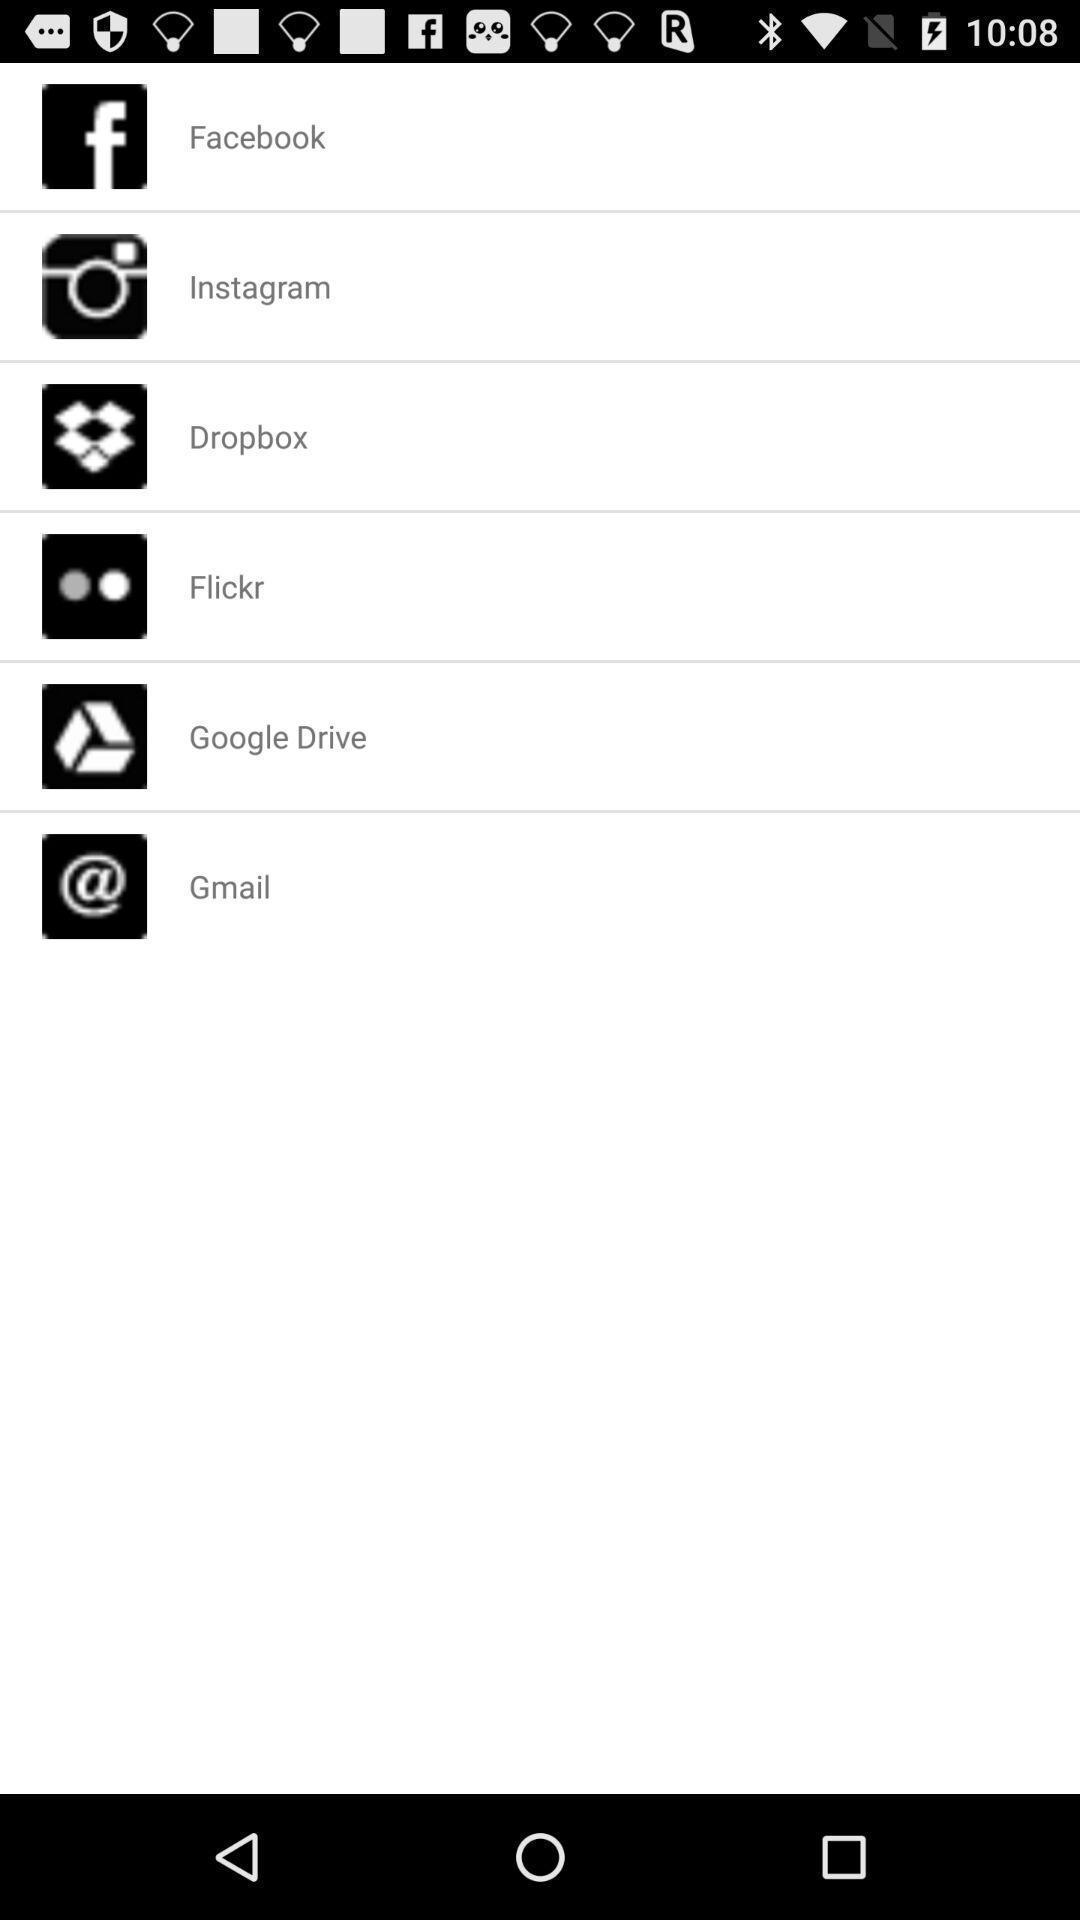Provide a detailed account of this screenshot. Page displaying list of different social applications. 